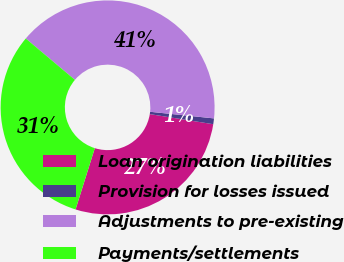<chart> <loc_0><loc_0><loc_500><loc_500><pie_chart><fcel>Loan origination liabilities<fcel>Provision for losses issued<fcel>Adjustments to pre-existing<fcel>Payments/settlements<nl><fcel>27.33%<fcel>0.87%<fcel>40.51%<fcel>31.29%<nl></chart> 